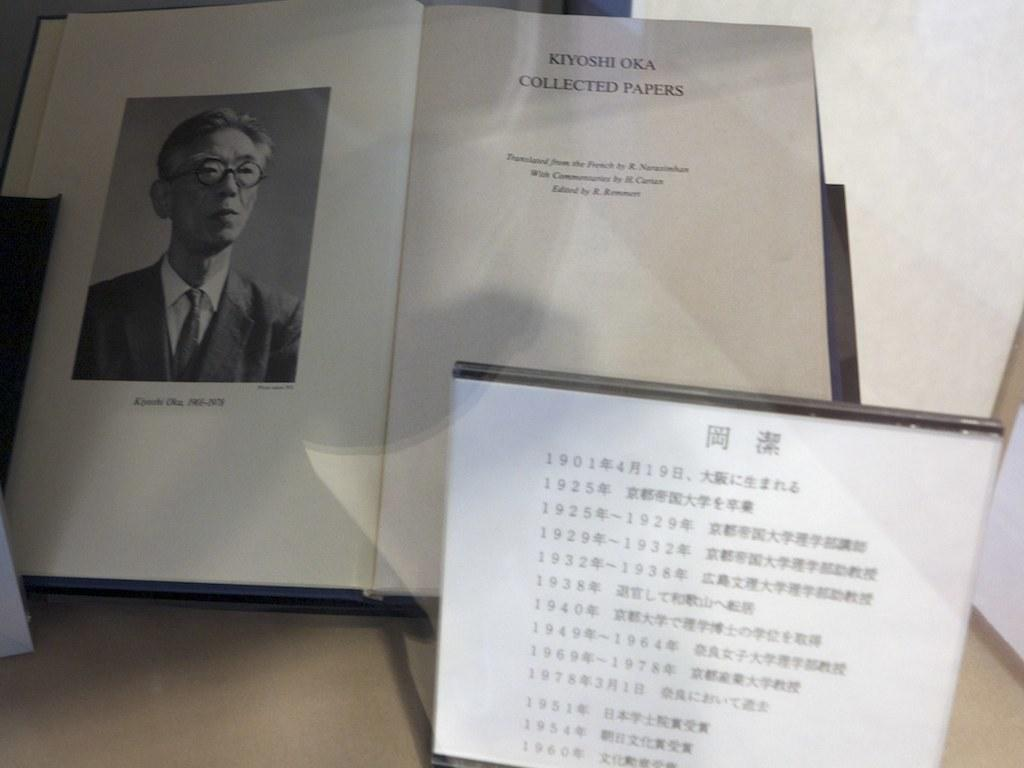What object in the image contains text? The book and the board in the image both have text on them. What type of content is on the book? The book has text on it, and there is also a photograph on the book. What is the other object in the image that has text? The board in the image has text on it. What type of rock is being used as a tray in the image? There is no rock or tray present in the image; it features a book and a board with text. Who is the partner mentioned in the text on the board? There is no mention of a partner in the text on the board or any other part of the image. 